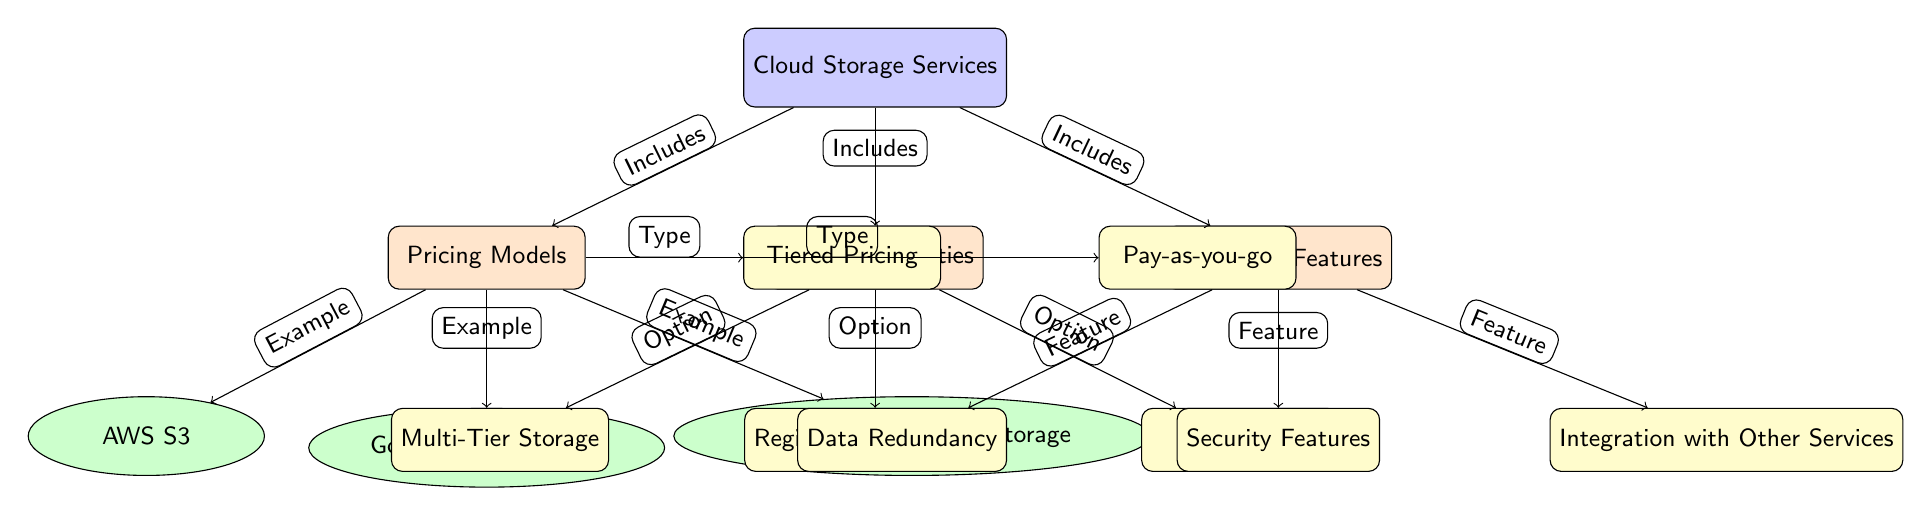What are the three main categories of cloud storage services depicted in the diagram? The diagram identifies three main categories represented as nodes below the main node "Cloud Storage Services." These categories are pricing models, storage capacities, and additional features.
Answer: Pricing Models, Storage Capacities, Additional Features Which cloud storage service is an example under the pricing models category? The diagram includes three cloud storage services as examples under the pricing models category. They are AWS S3, Google Cloud Storage, and Microsoft Azure Blob Storage.
Answer: AWS S3, Google Cloud Storage, Microsoft Azure Blob Storage What type of pricing model is mentioned in the diagram? The diagram presents two types of pricing models related to cloud storage services: tiered pricing and pay-as-you-go. These types branch directly from the pricing models category.
Answer: Tiered Pricing, Pay-as-you-go How many options are included under the storage capacities category? The storage capacities category contains three options, represented as nodes branching down from it. The options are multi-tier storage, region-specific pricing, and free tier.
Answer: 3 What feature under "Additional Features" focuses on safeguarding user data? Under the additional features category, "Data Redundancy" is listed as a feature specifically related to safeguarding user data.
Answer: Data Redundancy What connection types exist between the main categories and their respective subcategories? The connections from the main categories to their respective subcategories indicate that each category includes specific types or options, suggesting a hierarchical relationship where the main categories lead to examples or options within the subcategories.
Answer: Includes, Type, Option, Feature Which feature relates to the integration of services within cloud storage? The feature "Integration with Other Services" falls under the additional features category, representing the ability of cloud storage to work with other technology solutions.
Answer: Integration with Other Services Which cloud storage service mentioned uses a tiered pricing model? The AWS S3 service is referenced as an example under the pricing models category, indicating that it employs a tiered pricing model.
Answer: AWS S3 